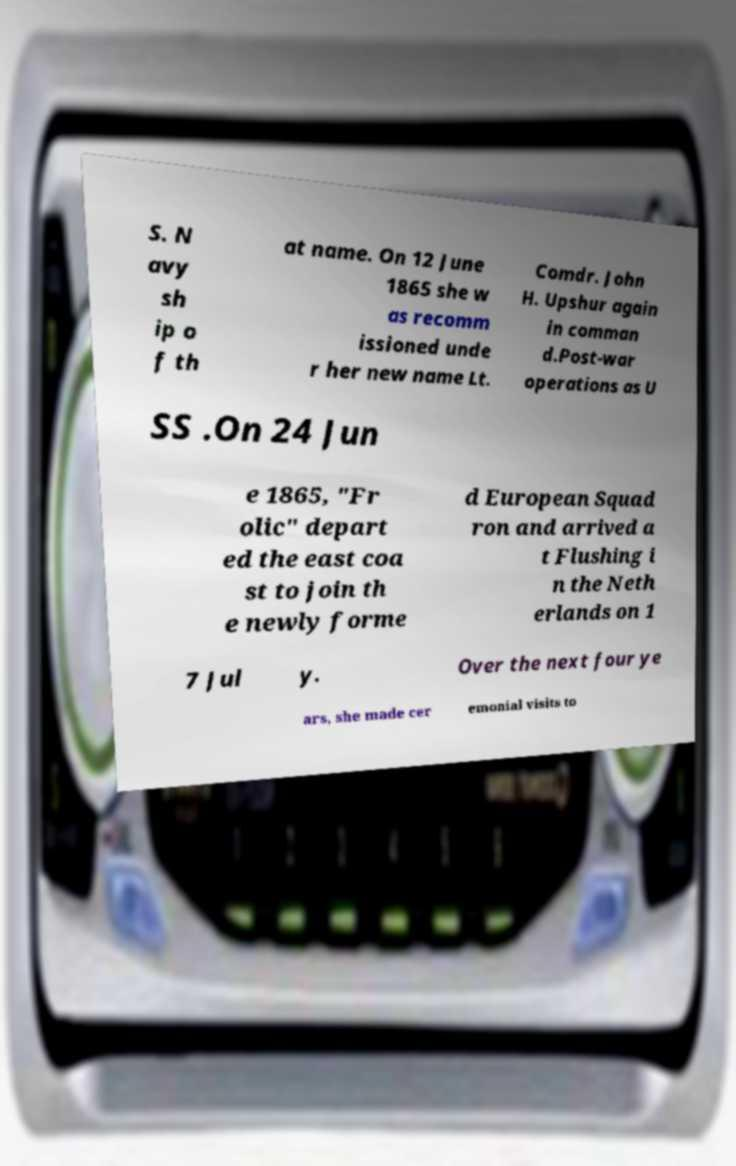Could you extract and type out the text from this image? S. N avy sh ip o f th at name. On 12 June 1865 she w as recomm issioned unde r her new name Lt. Comdr. John H. Upshur again in comman d.Post-war operations as U SS .On 24 Jun e 1865, "Fr olic" depart ed the east coa st to join th e newly forme d European Squad ron and arrived a t Flushing i n the Neth erlands on 1 7 Jul y. Over the next four ye ars, she made cer emonial visits to 